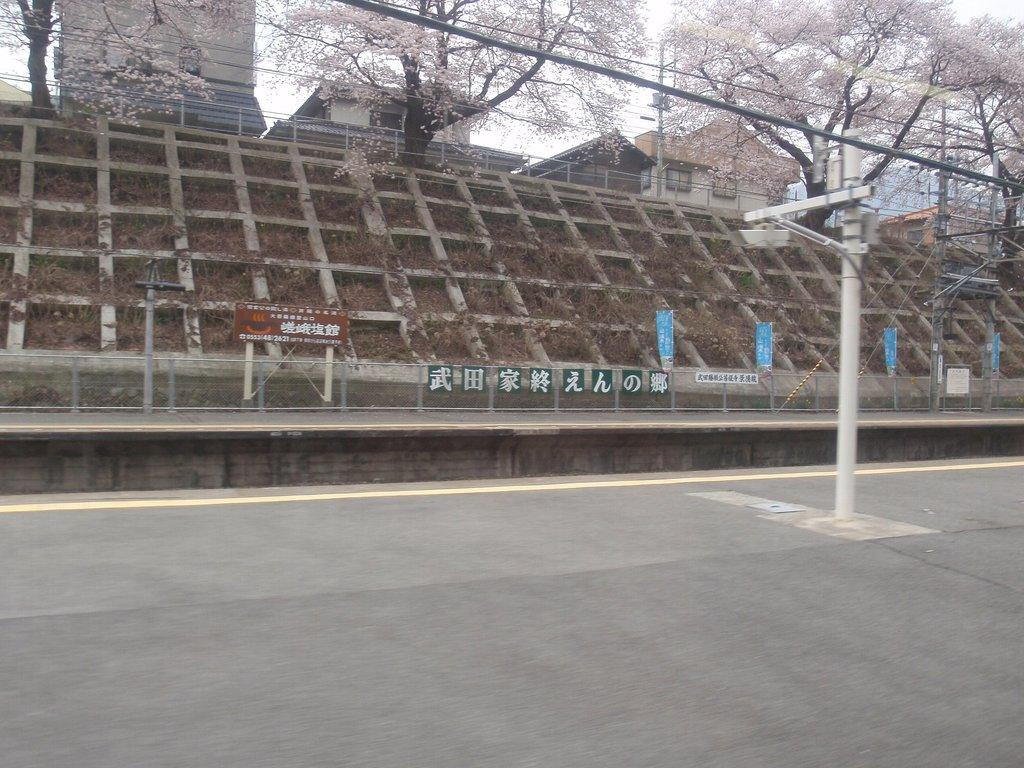What object can be seen on the right side of the image? There is a pole on the right side of the image. What is located in the middle of the image? There are boards in the middle of the image. What type of material is used for the net in the image? There is an iron net in the image. What structures can be seen at the top of the image? There are buildings and trees visible at the top of the image. What is visible in the background of the image? The sky is visible at the top of the image. What type of zinc is present in the image? There is no zinc present in the image. What belief system is being practiced by the stranger in the image? There is no stranger present in the image, so it is not possible to determine any belief system being practiced. 